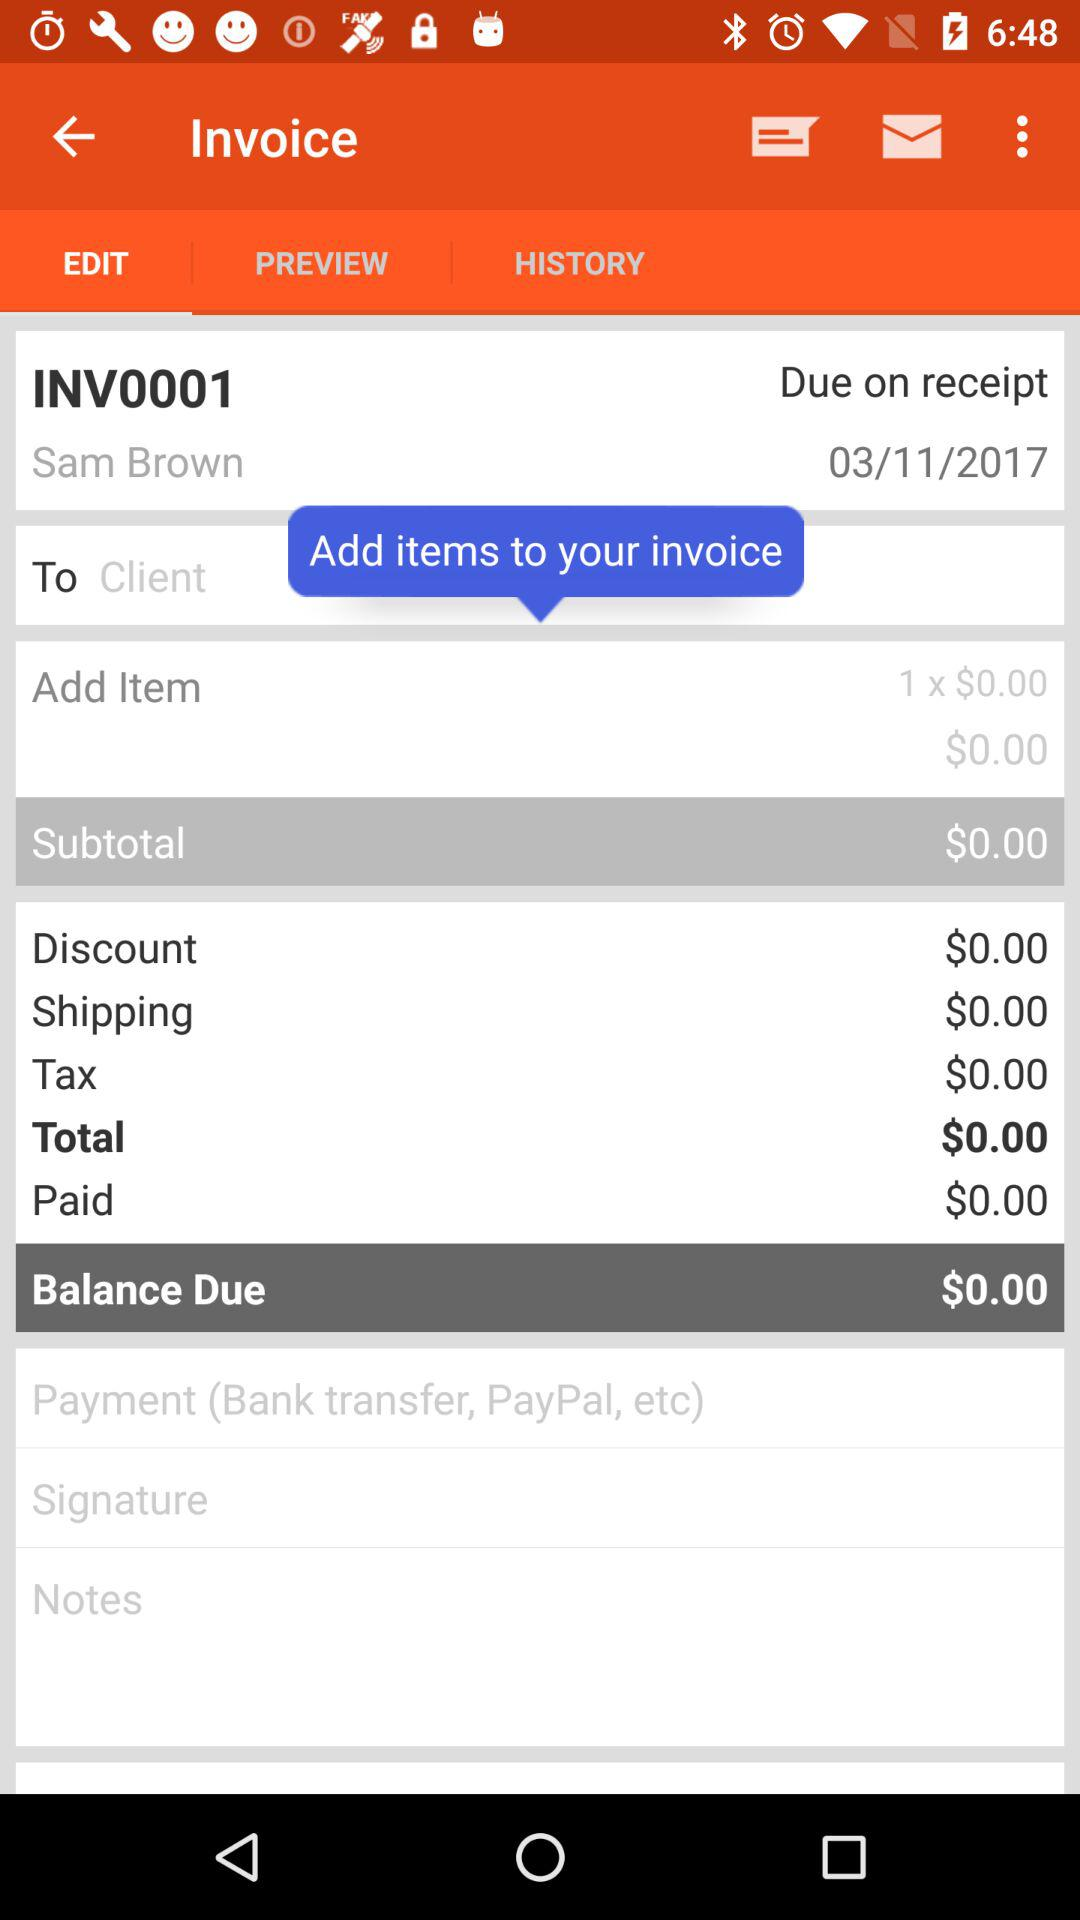What's the invoice number? The invoice number is INV001. 